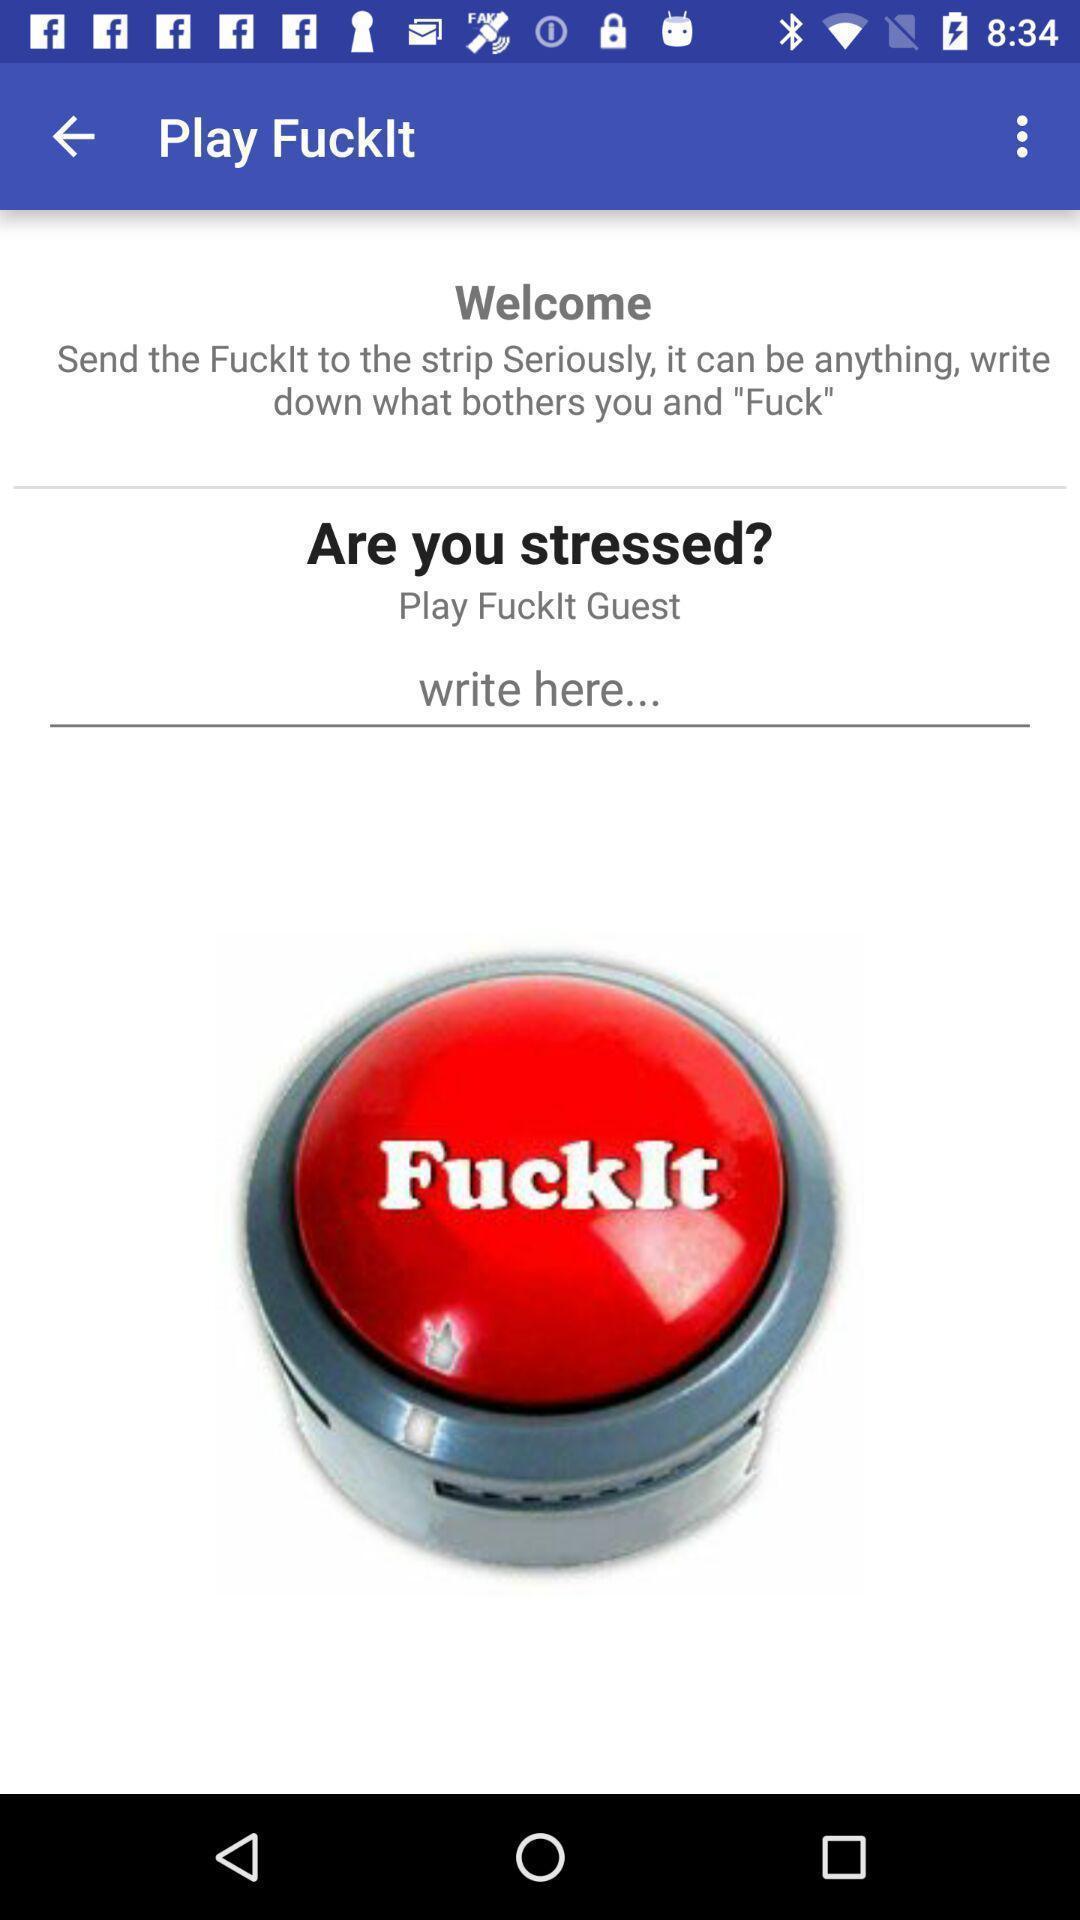Provide a description of this screenshot. Welcome page. 